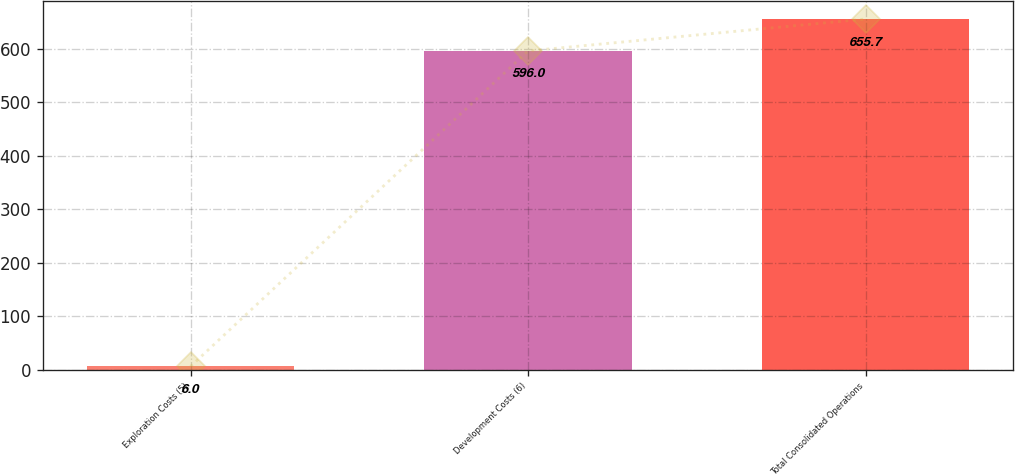<chart> <loc_0><loc_0><loc_500><loc_500><bar_chart><fcel>Exploration Costs (5)<fcel>Development Costs (6)<fcel>Total Consolidated Operations<nl><fcel>6<fcel>596<fcel>655.7<nl></chart> 